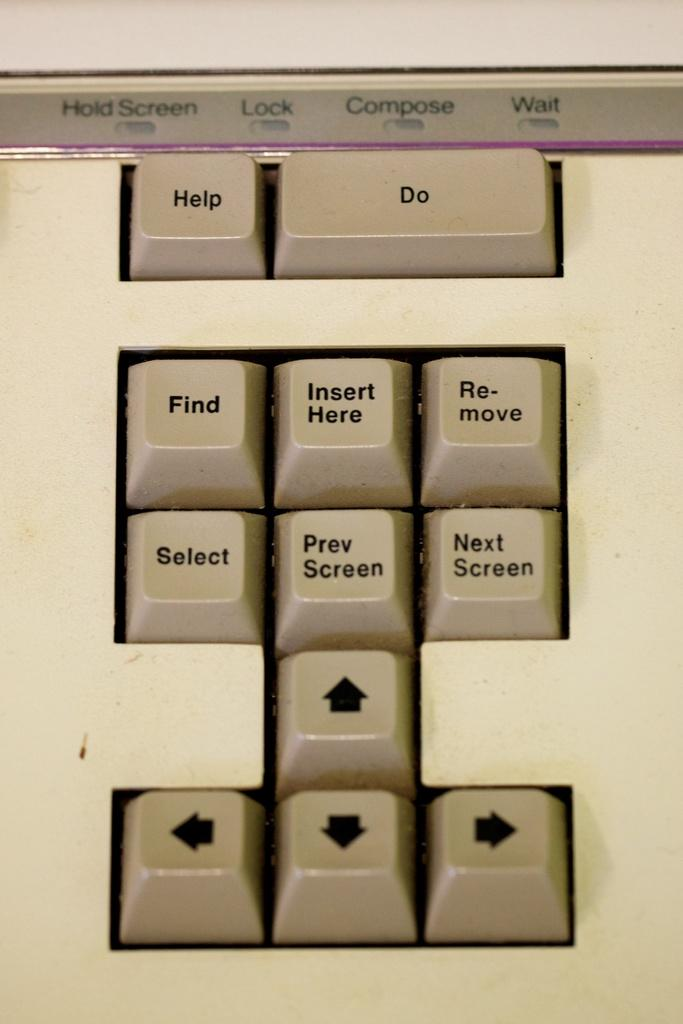Provide a one-sentence caption for the provided image. A keyboard with many keys including find, select and help. 